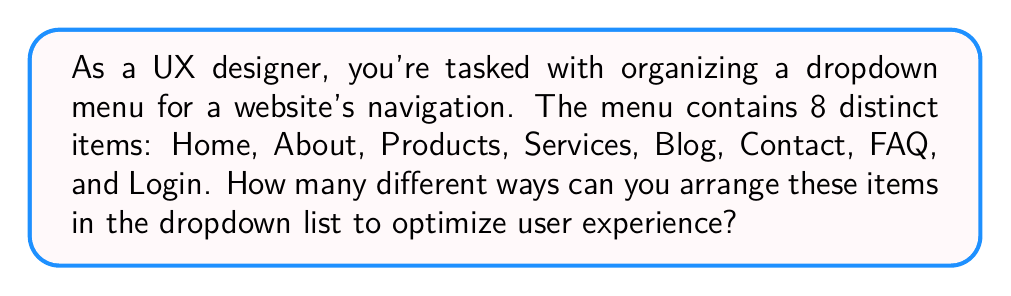Provide a solution to this math problem. To solve this problem, we need to consider the concept of permutations. Since we're arranging all 8 items in a specific order, and each item can only be used once, this is a straightforward permutation problem.

The formula for permutations of n distinct objects is:

$$P(n) = n!$$

Where $n!$ represents the factorial of n.

In this case, we have 8 distinct menu items, so $n = 8$.

Let's calculate step by step:

1) $8! = 8 \times 7 \times 6 \times 5 \times 4 \times 3 \times 2 \times 1$

2) $8! = 40,320$

Therefore, there are 40,320 different ways to arrange the 8 menu items in the dropdown list.

From a UX perspective, while this number represents all possible arrangements, the designer would need to consider factors such as user expectations, frequency of use, and logical grouping to determine the most effective arrangement.
Answer: $40,320$ 